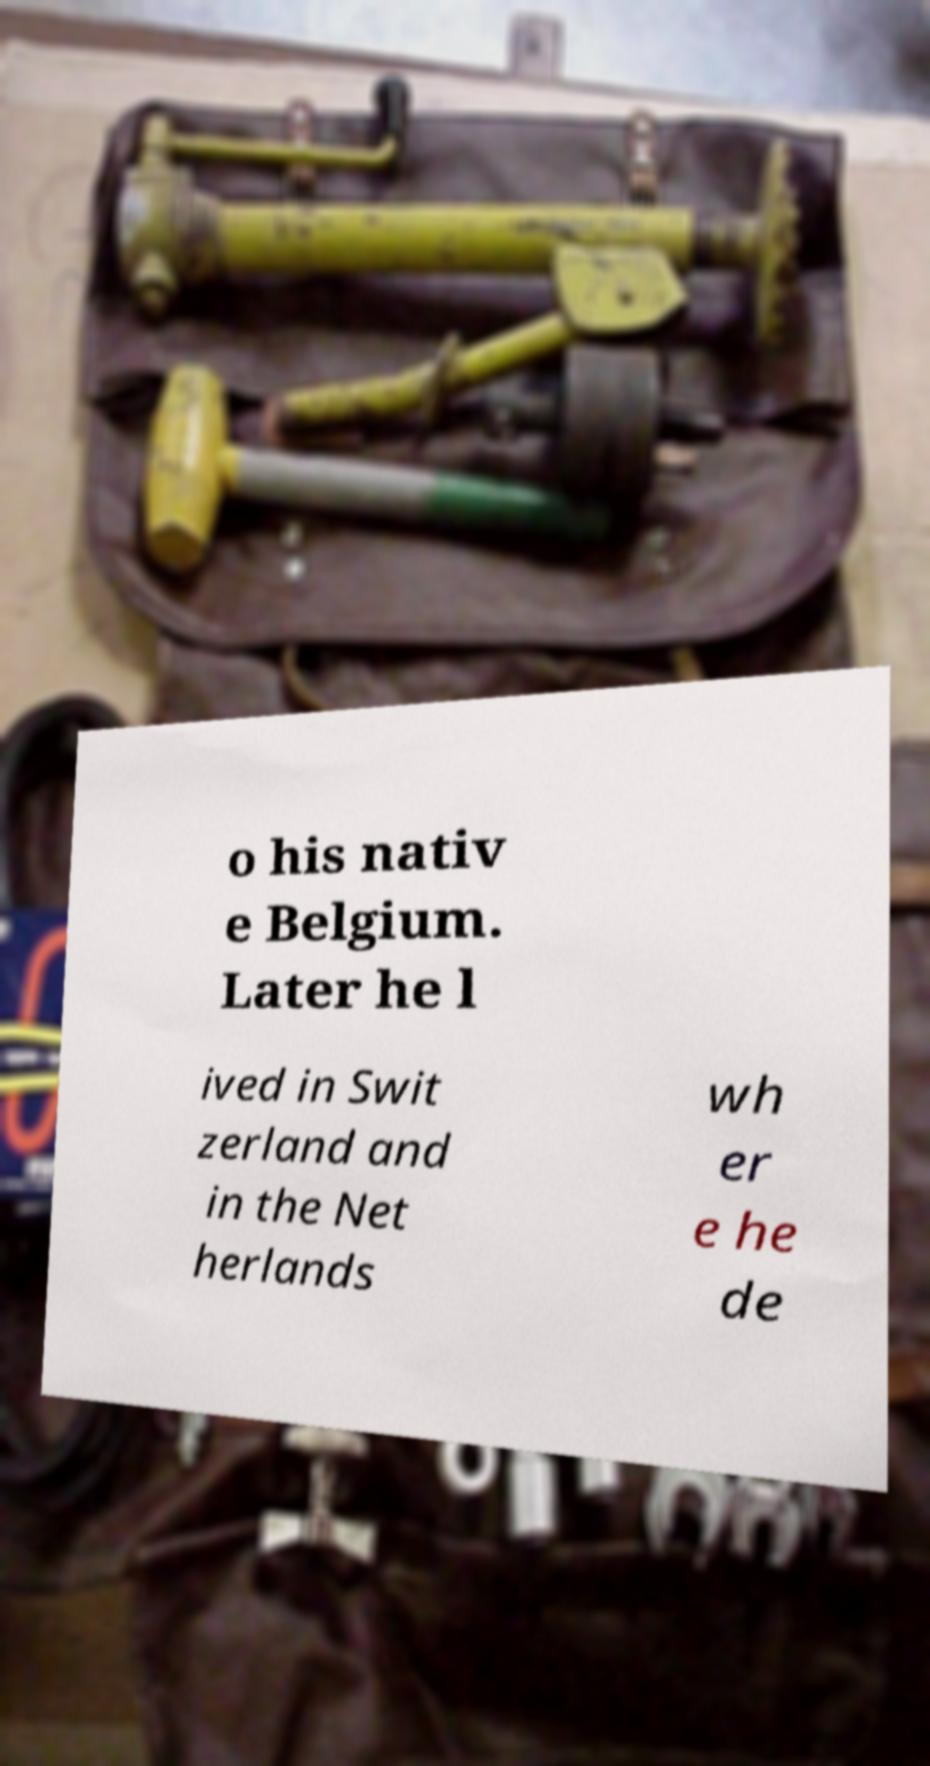Can you read and provide the text displayed in the image?This photo seems to have some interesting text. Can you extract and type it out for me? o his nativ e Belgium. Later he l ived in Swit zerland and in the Net herlands wh er e he de 